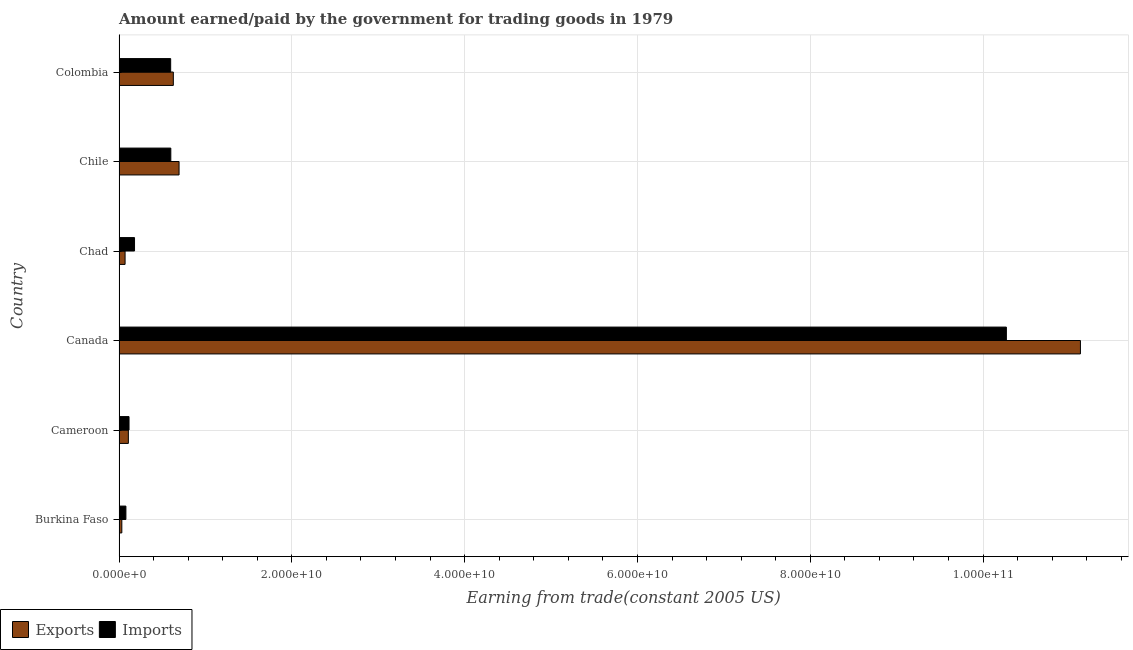Are the number of bars on each tick of the Y-axis equal?
Keep it short and to the point. Yes. How many bars are there on the 6th tick from the top?
Give a very brief answer. 2. What is the label of the 5th group of bars from the top?
Offer a very short reply. Cameroon. In how many cases, is the number of bars for a given country not equal to the number of legend labels?
Make the answer very short. 0. What is the amount paid for imports in Chad?
Give a very brief answer. 1.79e+09. Across all countries, what is the maximum amount earned from exports?
Your answer should be compact. 1.11e+11. Across all countries, what is the minimum amount paid for imports?
Offer a terse response. 7.94e+08. In which country was the amount paid for imports maximum?
Your answer should be very brief. Canada. In which country was the amount paid for imports minimum?
Ensure brevity in your answer.  Burkina Faso. What is the total amount earned from exports in the graph?
Make the answer very short. 1.27e+11. What is the difference between the amount earned from exports in Burkina Faso and that in Chad?
Make the answer very short. -3.77e+08. What is the difference between the amount earned from exports in Burkina Faso and the amount paid for imports in Chile?
Your answer should be very brief. -5.67e+09. What is the average amount earned from exports per country?
Offer a terse response. 2.11e+1. What is the difference between the amount paid for imports and amount earned from exports in Cameroon?
Keep it short and to the point. 7.70e+07. In how many countries, is the amount paid for imports greater than 92000000000 US$?
Your answer should be compact. 1. What is the ratio of the amount paid for imports in Burkina Faso to that in Canada?
Ensure brevity in your answer.  0.01. Is the difference between the amount earned from exports in Cameroon and Canada greater than the difference between the amount paid for imports in Cameroon and Canada?
Offer a very short reply. No. What is the difference between the highest and the second highest amount paid for imports?
Provide a short and direct response. 9.67e+1. What is the difference between the highest and the lowest amount earned from exports?
Your response must be concise. 1.11e+11. In how many countries, is the amount paid for imports greater than the average amount paid for imports taken over all countries?
Your response must be concise. 1. What does the 1st bar from the top in Chile represents?
Your answer should be compact. Imports. What does the 1st bar from the bottom in Colombia represents?
Provide a short and direct response. Exports. What is the difference between two consecutive major ticks on the X-axis?
Offer a terse response. 2.00e+1. Does the graph contain any zero values?
Your answer should be compact. No. What is the title of the graph?
Offer a terse response. Amount earned/paid by the government for trading goods in 1979. Does "Female" appear as one of the legend labels in the graph?
Give a very brief answer. No. What is the label or title of the X-axis?
Offer a very short reply. Earning from trade(constant 2005 US). What is the Earning from trade(constant 2005 US) in Exports in Burkina Faso?
Offer a terse response. 3.21e+08. What is the Earning from trade(constant 2005 US) in Imports in Burkina Faso?
Your answer should be compact. 7.94e+08. What is the Earning from trade(constant 2005 US) in Exports in Cameroon?
Offer a very short reply. 1.08e+09. What is the Earning from trade(constant 2005 US) of Imports in Cameroon?
Your response must be concise. 1.15e+09. What is the Earning from trade(constant 2005 US) in Exports in Canada?
Offer a very short reply. 1.11e+11. What is the Earning from trade(constant 2005 US) in Imports in Canada?
Ensure brevity in your answer.  1.03e+11. What is the Earning from trade(constant 2005 US) in Exports in Chad?
Provide a short and direct response. 6.98e+08. What is the Earning from trade(constant 2005 US) in Imports in Chad?
Offer a terse response. 1.79e+09. What is the Earning from trade(constant 2005 US) in Exports in Chile?
Make the answer very short. 6.94e+09. What is the Earning from trade(constant 2005 US) in Imports in Chile?
Your response must be concise. 5.99e+09. What is the Earning from trade(constant 2005 US) in Exports in Colombia?
Offer a very short reply. 6.28e+09. What is the Earning from trade(constant 2005 US) of Imports in Colombia?
Give a very brief answer. 5.97e+09. Across all countries, what is the maximum Earning from trade(constant 2005 US) in Exports?
Offer a very short reply. 1.11e+11. Across all countries, what is the maximum Earning from trade(constant 2005 US) in Imports?
Offer a terse response. 1.03e+11. Across all countries, what is the minimum Earning from trade(constant 2005 US) in Exports?
Your answer should be compact. 3.21e+08. Across all countries, what is the minimum Earning from trade(constant 2005 US) in Imports?
Offer a terse response. 7.94e+08. What is the total Earning from trade(constant 2005 US) in Exports in the graph?
Ensure brevity in your answer.  1.27e+11. What is the total Earning from trade(constant 2005 US) in Imports in the graph?
Provide a short and direct response. 1.18e+11. What is the difference between the Earning from trade(constant 2005 US) in Exports in Burkina Faso and that in Cameroon?
Your answer should be compact. -7.56e+08. What is the difference between the Earning from trade(constant 2005 US) of Imports in Burkina Faso and that in Cameroon?
Ensure brevity in your answer.  -3.60e+08. What is the difference between the Earning from trade(constant 2005 US) of Exports in Burkina Faso and that in Canada?
Keep it short and to the point. -1.11e+11. What is the difference between the Earning from trade(constant 2005 US) in Imports in Burkina Faso and that in Canada?
Offer a terse response. -1.02e+11. What is the difference between the Earning from trade(constant 2005 US) of Exports in Burkina Faso and that in Chad?
Your answer should be compact. -3.77e+08. What is the difference between the Earning from trade(constant 2005 US) in Imports in Burkina Faso and that in Chad?
Provide a short and direct response. -9.97e+08. What is the difference between the Earning from trade(constant 2005 US) of Exports in Burkina Faso and that in Chile?
Give a very brief answer. -6.62e+09. What is the difference between the Earning from trade(constant 2005 US) of Imports in Burkina Faso and that in Chile?
Make the answer very short. -5.20e+09. What is the difference between the Earning from trade(constant 2005 US) of Exports in Burkina Faso and that in Colombia?
Give a very brief answer. -5.96e+09. What is the difference between the Earning from trade(constant 2005 US) in Imports in Burkina Faso and that in Colombia?
Offer a terse response. -5.18e+09. What is the difference between the Earning from trade(constant 2005 US) of Exports in Cameroon and that in Canada?
Provide a succinct answer. -1.10e+11. What is the difference between the Earning from trade(constant 2005 US) of Imports in Cameroon and that in Canada?
Your response must be concise. -1.02e+11. What is the difference between the Earning from trade(constant 2005 US) of Exports in Cameroon and that in Chad?
Your answer should be very brief. 3.79e+08. What is the difference between the Earning from trade(constant 2005 US) in Imports in Cameroon and that in Chad?
Provide a short and direct response. -6.37e+08. What is the difference between the Earning from trade(constant 2005 US) in Exports in Cameroon and that in Chile?
Keep it short and to the point. -5.87e+09. What is the difference between the Earning from trade(constant 2005 US) of Imports in Cameroon and that in Chile?
Offer a very short reply. -4.84e+09. What is the difference between the Earning from trade(constant 2005 US) of Exports in Cameroon and that in Colombia?
Keep it short and to the point. -5.20e+09. What is the difference between the Earning from trade(constant 2005 US) in Imports in Cameroon and that in Colombia?
Make the answer very short. -4.82e+09. What is the difference between the Earning from trade(constant 2005 US) of Exports in Canada and that in Chad?
Keep it short and to the point. 1.11e+11. What is the difference between the Earning from trade(constant 2005 US) of Imports in Canada and that in Chad?
Make the answer very short. 1.01e+11. What is the difference between the Earning from trade(constant 2005 US) in Exports in Canada and that in Chile?
Keep it short and to the point. 1.04e+11. What is the difference between the Earning from trade(constant 2005 US) in Imports in Canada and that in Chile?
Provide a succinct answer. 9.67e+1. What is the difference between the Earning from trade(constant 2005 US) of Exports in Canada and that in Colombia?
Keep it short and to the point. 1.05e+11. What is the difference between the Earning from trade(constant 2005 US) of Imports in Canada and that in Colombia?
Ensure brevity in your answer.  9.67e+1. What is the difference between the Earning from trade(constant 2005 US) in Exports in Chad and that in Chile?
Provide a short and direct response. -6.25e+09. What is the difference between the Earning from trade(constant 2005 US) of Imports in Chad and that in Chile?
Give a very brief answer. -4.20e+09. What is the difference between the Earning from trade(constant 2005 US) of Exports in Chad and that in Colombia?
Keep it short and to the point. -5.58e+09. What is the difference between the Earning from trade(constant 2005 US) in Imports in Chad and that in Colombia?
Keep it short and to the point. -4.18e+09. What is the difference between the Earning from trade(constant 2005 US) of Exports in Chile and that in Colombia?
Ensure brevity in your answer.  6.64e+08. What is the difference between the Earning from trade(constant 2005 US) of Imports in Chile and that in Colombia?
Provide a succinct answer. 1.63e+07. What is the difference between the Earning from trade(constant 2005 US) in Exports in Burkina Faso and the Earning from trade(constant 2005 US) in Imports in Cameroon?
Ensure brevity in your answer.  -8.33e+08. What is the difference between the Earning from trade(constant 2005 US) of Exports in Burkina Faso and the Earning from trade(constant 2005 US) of Imports in Canada?
Give a very brief answer. -1.02e+11. What is the difference between the Earning from trade(constant 2005 US) in Exports in Burkina Faso and the Earning from trade(constant 2005 US) in Imports in Chad?
Offer a very short reply. -1.47e+09. What is the difference between the Earning from trade(constant 2005 US) of Exports in Burkina Faso and the Earning from trade(constant 2005 US) of Imports in Chile?
Provide a succinct answer. -5.67e+09. What is the difference between the Earning from trade(constant 2005 US) of Exports in Burkina Faso and the Earning from trade(constant 2005 US) of Imports in Colombia?
Your response must be concise. -5.65e+09. What is the difference between the Earning from trade(constant 2005 US) of Exports in Cameroon and the Earning from trade(constant 2005 US) of Imports in Canada?
Provide a succinct answer. -1.02e+11. What is the difference between the Earning from trade(constant 2005 US) in Exports in Cameroon and the Earning from trade(constant 2005 US) in Imports in Chad?
Keep it short and to the point. -7.14e+08. What is the difference between the Earning from trade(constant 2005 US) of Exports in Cameroon and the Earning from trade(constant 2005 US) of Imports in Chile?
Provide a short and direct response. -4.91e+09. What is the difference between the Earning from trade(constant 2005 US) in Exports in Cameroon and the Earning from trade(constant 2005 US) in Imports in Colombia?
Keep it short and to the point. -4.90e+09. What is the difference between the Earning from trade(constant 2005 US) of Exports in Canada and the Earning from trade(constant 2005 US) of Imports in Chad?
Provide a succinct answer. 1.09e+11. What is the difference between the Earning from trade(constant 2005 US) in Exports in Canada and the Earning from trade(constant 2005 US) in Imports in Chile?
Offer a very short reply. 1.05e+11. What is the difference between the Earning from trade(constant 2005 US) of Exports in Canada and the Earning from trade(constant 2005 US) of Imports in Colombia?
Your answer should be compact. 1.05e+11. What is the difference between the Earning from trade(constant 2005 US) of Exports in Chad and the Earning from trade(constant 2005 US) of Imports in Chile?
Your answer should be compact. -5.29e+09. What is the difference between the Earning from trade(constant 2005 US) of Exports in Chad and the Earning from trade(constant 2005 US) of Imports in Colombia?
Keep it short and to the point. -5.28e+09. What is the difference between the Earning from trade(constant 2005 US) in Exports in Chile and the Earning from trade(constant 2005 US) in Imports in Colombia?
Provide a succinct answer. 9.71e+08. What is the average Earning from trade(constant 2005 US) in Exports per country?
Provide a short and direct response. 2.11e+1. What is the average Earning from trade(constant 2005 US) of Imports per country?
Offer a very short reply. 1.97e+1. What is the difference between the Earning from trade(constant 2005 US) in Exports and Earning from trade(constant 2005 US) in Imports in Burkina Faso?
Your answer should be very brief. -4.73e+08. What is the difference between the Earning from trade(constant 2005 US) in Exports and Earning from trade(constant 2005 US) in Imports in Cameroon?
Ensure brevity in your answer.  -7.70e+07. What is the difference between the Earning from trade(constant 2005 US) in Exports and Earning from trade(constant 2005 US) in Imports in Canada?
Your answer should be compact. 8.57e+09. What is the difference between the Earning from trade(constant 2005 US) of Exports and Earning from trade(constant 2005 US) of Imports in Chad?
Your answer should be very brief. -1.09e+09. What is the difference between the Earning from trade(constant 2005 US) in Exports and Earning from trade(constant 2005 US) in Imports in Chile?
Offer a terse response. 9.55e+08. What is the difference between the Earning from trade(constant 2005 US) of Exports and Earning from trade(constant 2005 US) of Imports in Colombia?
Ensure brevity in your answer.  3.08e+08. What is the ratio of the Earning from trade(constant 2005 US) in Exports in Burkina Faso to that in Cameroon?
Give a very brief answer. 0.3. What is the ratio of the Earning from trade(constant 2005 US) of Imports in Burkina Faso to that in Cameroon?
Make the answer very short. 0.69. What is the ratio of the Earning from trade(constant 2005 US) of Exports in Burkina Faso to that in Canada?
Offer a very short reply. 0. What is the ratio of the Earning from trade(constant 2005 US) of Imports in Burkina Faso to that in Canada?
Provide a succinct answer. 0.01. What is the ratio of the Earning from trade(constant 2005 US) in Exports in Burkina Faso to that in Chad?
Ensure brevity in your answer.  0.46. What is the ratio of the Earning from trade(constant 2005 US) in Imports in Burkina Faso to that in Chad?
Your response must be concise. 0.44. What is the ratio of the Earning from trade(constant 2005 US) of Exports in Burkina Faso to that in Chile?
Provide a succinct answer. 0.05. What is the ratio of the Earning from trade(constant 2005 US) of Imports in Burkina Faso to that in Chile?
Your response must be concise. 0.13. What is the ratio of the Earning from trade(constant 2005 US) in Exports in Burkina Faso to that in Colombia?
Provide a short and direct response. 0.05. What is the ratio of the Earning from trade(constant 2005 US) of Imports in Burkina Faso to that in Colombia?
Offer a very short reply. 0.13. What is the ratio of the Earning from trade(constant 2005 US) of Exports in Cameroon to that in Canada?
Make the answer very short. 0.01. What is the ratio of the Earning from trade(constant 2005 US) in Imports in Cameroon to that in Canada?
Your answer should be very brief. 0.01. What is the ratio of the Earning from trade(constant 2005 US) in Exports in Cameroon to that in Chad?
Make the answer very short. 1.54. What is the ratio of the Earning from trade(constant 2005 US) of Imports in Cameroon to that in Chad?
Offer a terse response. 0.64. What is the ratio of the Earning from trade(constant 2005 US) in Exports in Cameroon to that in Chile?
Your response must be concise. 0.16. What is the ratio of the Earning from trade(constant 2005 US) in Imports in Cameroon to that in Chile?
Make the answer very short. 0.19. What is the ratio of the Earning from trade(constant 2005 US) in Exports in Cameroon to that in Colombia?
Your answer should be compact. 0.17. What is the ratio of the Earning from trade(constant 2005 US) in Imports in Cameroon to that in Colombia?
Ensure brevity in your answer.  0.19. What is the ratio of the Earning from trade(constant 2005 US) of Exports in Canada to that in Chad?
Provide a succinct answer. 159.38. What is the ratio of the Earning from trade(constant 2005 US) in Imports in Canada to that in Chad?
Provide a succinct answer. 57.34. What is the ratio of the Earning from trade(constant 2005 US) of Exports in Canada to that in Chile?
Ensure brevity in your answer.  16.02. What is the ratio of the Earning from trade(constant 2005 US) in Imports in Canada to that in Chile?
Your answer should be compact. 17.15. What is the ratio of the Earning from trade(constant 2005 US) of Exports in Canada to that in Colombia?
Keep it short and to the point. 17.71. What is the ratio of the Earning from trade(constant 2005 US) in Imports in Canada to that in Colombia?
Your response must be concise. 17.19. What is the ratio of the Earning from trade(constant 2005 US) of Exports in Chad to that in Chile?
Offer a very short reply. 0.1. What is the ratio of the Earning from trade(constant 2005 US) of Imports in Chad to that in Chile?
Make the answer very short. 0.3. What is the ratio of the Earning from trade(constant 2005 US) in Exports in Chad to that in Colombia?
Make the answer very short. 0.11. What is the ratio of the Earning from trade(constant 2005 US) of Imports in Chad to that in Colombia?
Your response must be concise. 0.3. What is the ratio of the Earning from trade(constant 2005 US) in Exports in Chile to that in Colombia?
Keep it short and to the point. 1.11. What is the difference between the highest and the second highest Earning from trade(constant 2005 US) of Exports?
Keep it short and to the point. 1.04e+11. What is the difference between the highest and the second highest Earning from trade(constant 2005 US) of Imports?
Give a very brief answer. 9.67e+1. What is the difference between the highest and the lowest Earning from trade(constant 2005 US) of Exports?
Offer a very short reply. 1.11e+11. What is the difference between the highest and the lowest Earning from trade(constant 2005 US) in Imports?
Provide a succinct answer. 1.02e+11. 